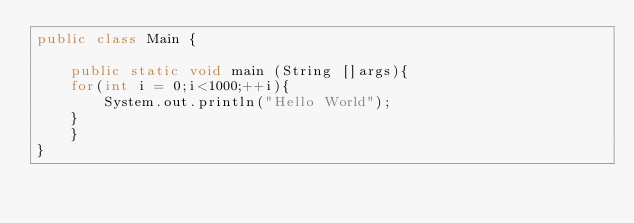<code> <loc_0><loc_0><loc_500><loc_500><_Java_>public class Main {

    public static void main (String []args){
	for(int i = 0;i<1000;++i){
	    System.out.println("Hello World");
	}
    }
}</code> 